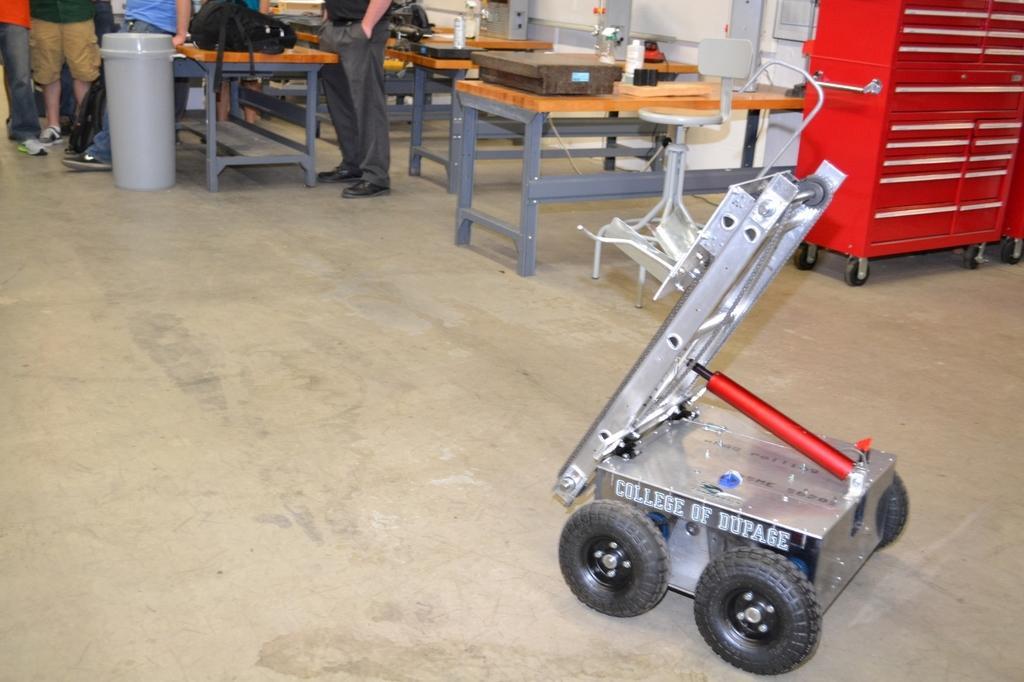In one or two sentences, can you explain what this image depicts? In this image I can see a machine. In the background I can see number of tables, a container and few people are standing. 